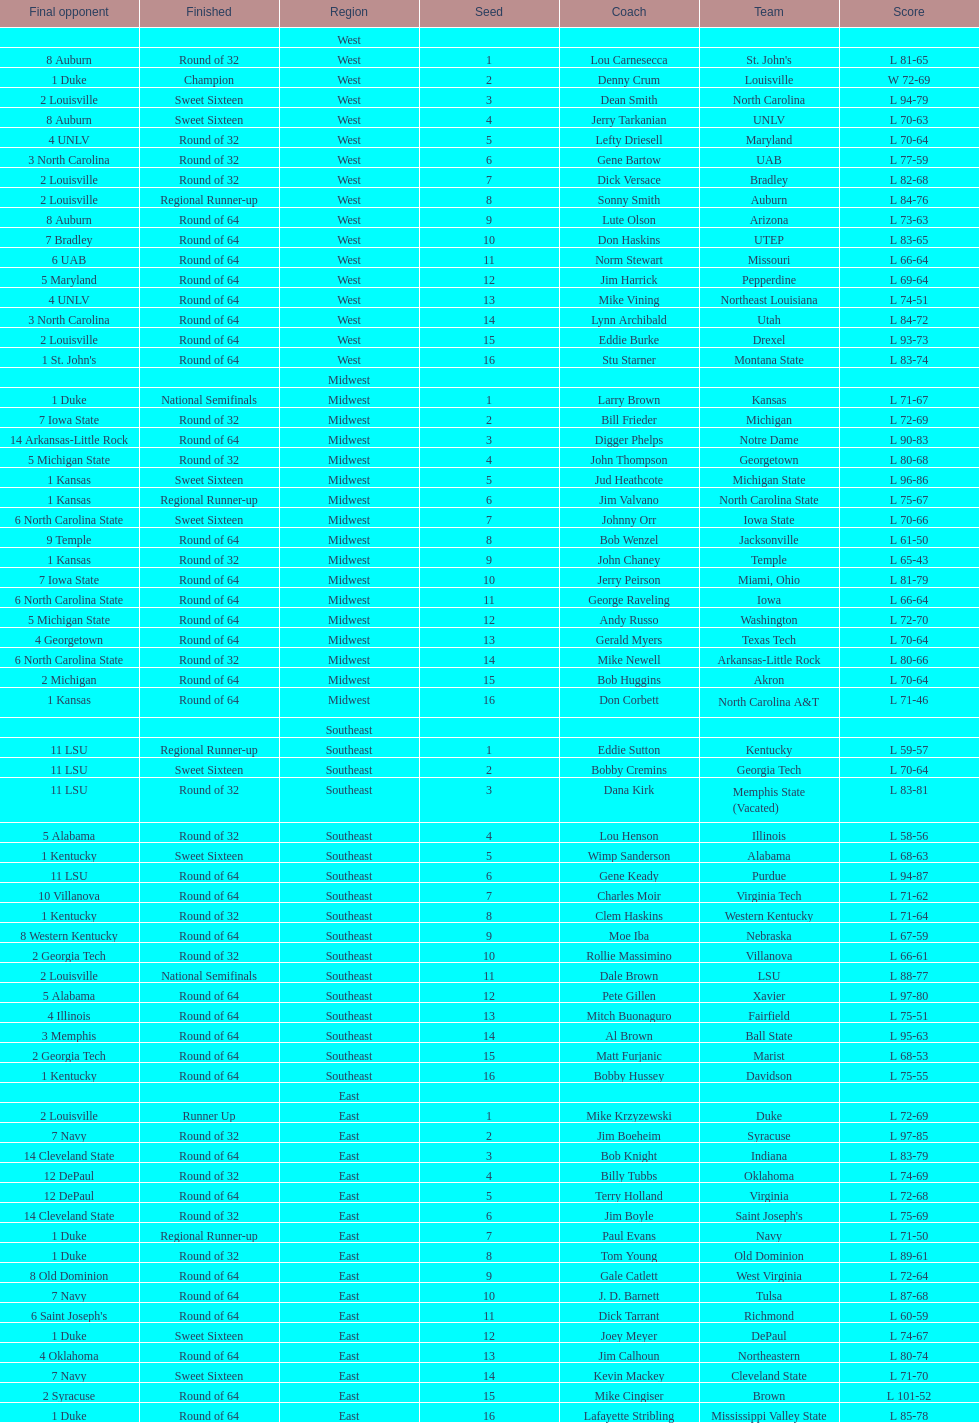Who is the only team from the east region to reach the final round? Duke. 